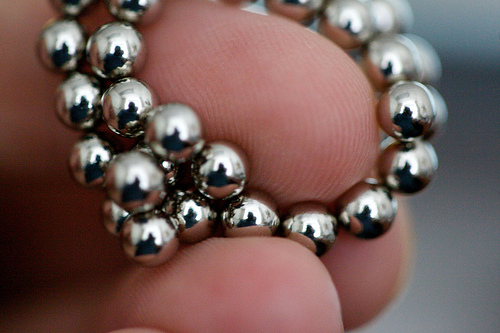<image>
Is the balls under the fingers? Yes. The balls is positioned underneath the fingers, with the fingers above it in the vertical space. Is there a jewelry in front of the finger? Yes. The jewelry is positioned in front of the finger, appearing closer to the camera viewpoint. 